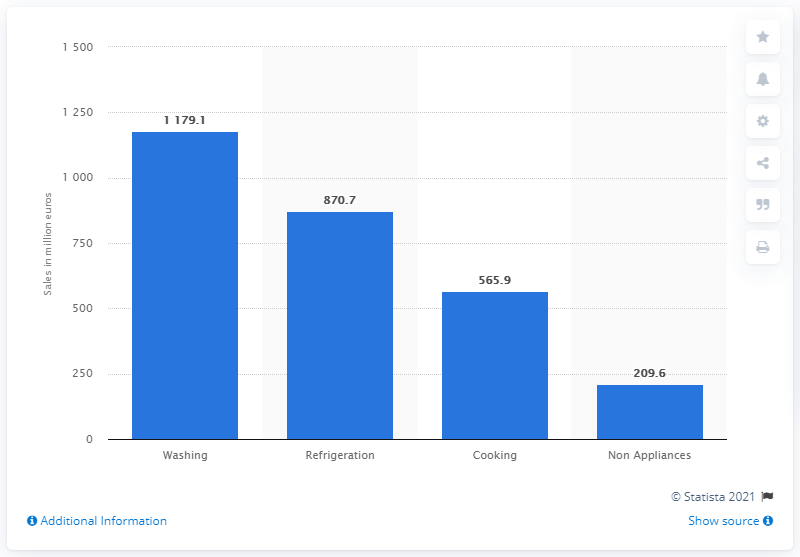Outline some significant characteristics in this image. In 2011, Indesit's sales of cooking appliances were 565.9 million units. 